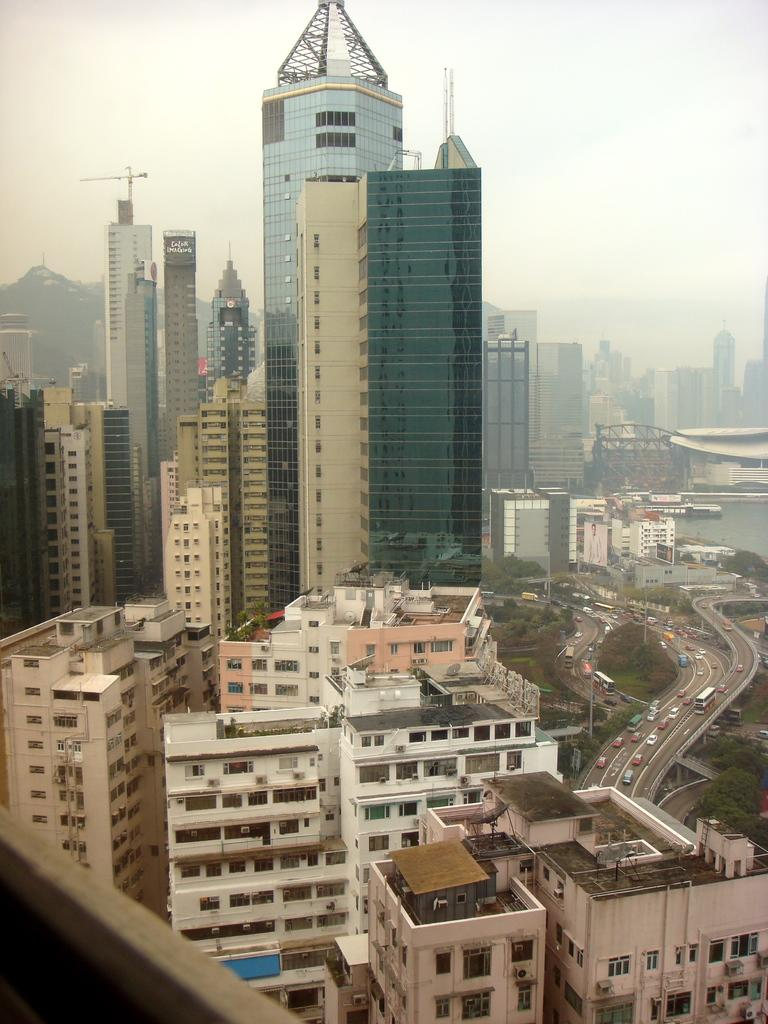What type of structures can be seen in the image? There are buildings in the image. What other natural elements are present in the image? There are trees in the image. What can be seen on the right side of the image? There are vehicles on the road on the right side of the image. What type of blade is being used to cut the linen in the image? There is no blade or linen present in the image. Can you describe the tramp in the image? There is no tramp present in the image. 